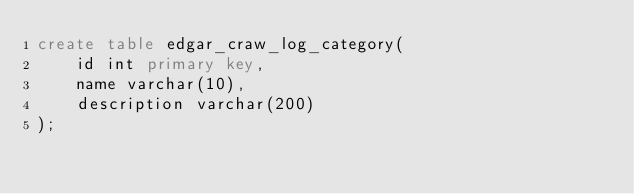<code> <loc_0><loc_0><loc_500><loc_500><_SQL_>create table edgar_craw_log_category(
    id int primary key,
    name varchar(10),
    description varchar(200)
);</code> 